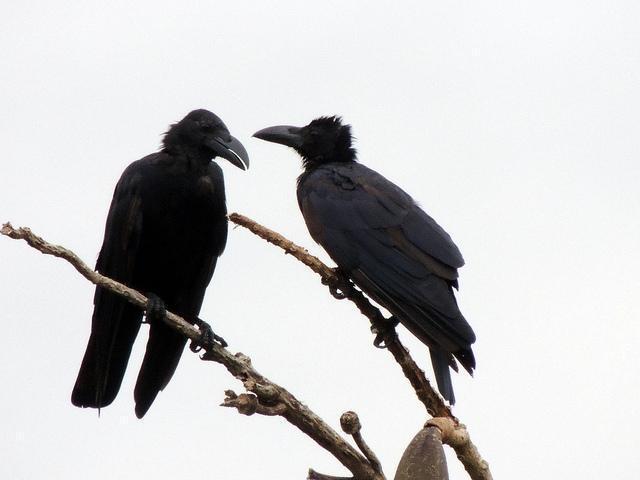How many birds can you see?
Give a very brief answer. 2. 